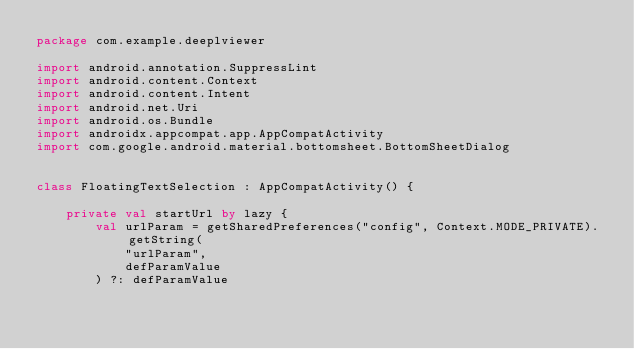Convert code to text. <code><loc_0><loc_0><loc_500><loc_500><_Kotlin_>package com.example.deeplviewer

import android.annotation.SuppressLint
import android.content.Context
import android.content.Intent
import android.net.Uri
import android.os.Bundle
import androidx.appcompat.app.AppCompatActivity
import com.google.android.material.bottomsheet.BottomSheetDialog


class FloatingTextSelection : AppCompatActivity() {

    private val startUrl by lazy {
        val urlParam = getSharedPreferences("config", Context.MODE_PRIVATE).getString(
            "urlParam",
            defParamValue
        ) ?: defParamValue</code> 